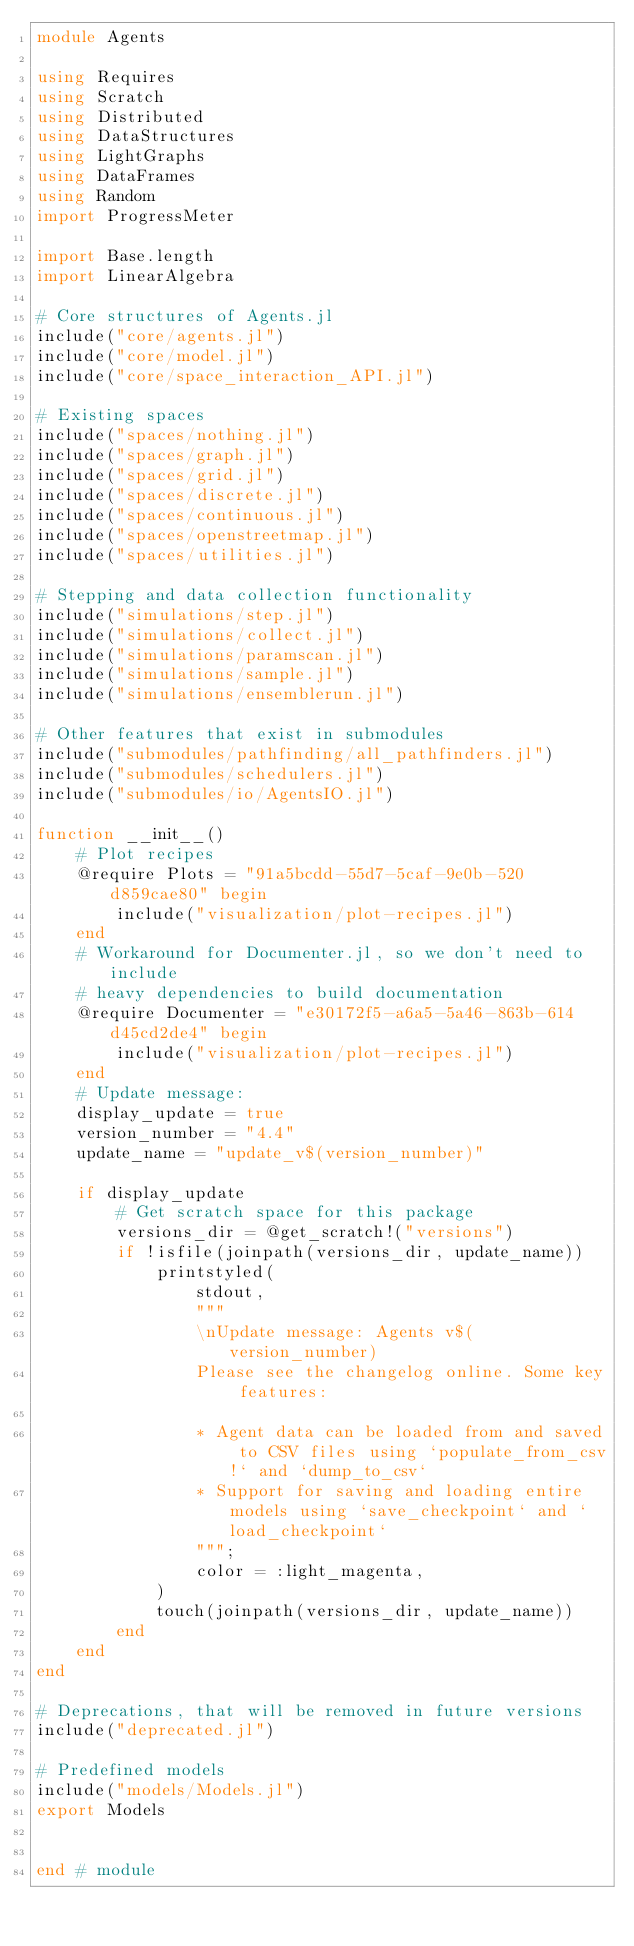Convert code to text. <code><loc_0><loc_0><loc_500><loc_500><_Julia_>module Agents

using Requires
using Scratch
using Distributed
using DataStructures
using LightGraphs
using DataFrames
using Random
import ProgressMeter

import Base.length
import LinearAlgebra

# Core structures of Agents.jl
include("core/agents.jl")
include("core/model.jl")
include("core/space_interaction_API.jl")

# Existing spaces
include("spaces/nothing.jl")
include("spaces/graph.jl")
include("spaces/grid.jl")
include("spaces/discrete.jl")
include("spaces/continuous.jl")
include("spaces/openstreetmap.jl")
include("spaces/utilities.jl")

# Stepping and data collection functionality
include("simulations/step.jl")
include("simulations/collect.jl")
include("simulations/paramscan.jl")
include("simulations/sample.jl")
include("simulations/ensemblerun.jl")

# Other features that exist in submodules
include("submodules/pathfinding/all_pathfinders.jl")
include("submodules/schedulers.jl")
include("submodules/io/AgentsIO.jl")

function __init__()
    # Plot recipes
    @require Plots = "91a5bcdd-55d7-5caf-9e0b-520d859cae80" begin
        include("visualization/plot-recipes.jl")
    end
    # Workaround for Documenter.jl, so we don't need to include
    # heavy dependencies to build documentation
    @require Documenter = "e30172f5-a6a5-5a46-863b-614d45cd2de4" begin
        include("visualization/plot-recipes.jl")
    end
    # Update message:
    display_update = true
    version_number = "4.4"
    update_name = "update_v$(version_number)"
    
    if display_update
        # Get scratch space for this package
        versions_dir = @get_scratch!("versions")
        if !isfile(joinpath(versions_dir, update_name))
            printstyled(
                stdout,
                """
                \nUpdate message: Agents v$(version_number)
                Please see the changelog online. Some key features:
    
                * Agent data can be loaded from and saved to CSV files using `populate_from_csv!` and `dump_to_csv`
                * Support for saving and loading entire models using `save_checkpoint` and `load_checkpoint`
                """;
                color = :light_magenta,
            )
            touch(joinpath(versions_dir, update_name))
        end
    end
end

# Deprecations, that will be removed in future versions
include("deprecated.jl")

# Predefined models
include("models/Models.jl")
export Models


end # module
</code> 